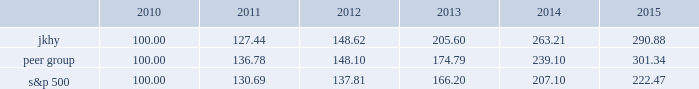18 2015 annual report performance graph the following chart presents a comparison for the five-year period ended june 30 , 2015 , of the market performance of the company 2019s common stock with the s&p 500 index and an index of peer companies selected by the company : comparison of 5 year cumulative total return among jack henry & associates , inc. , the s&p 500 index , and a peer group the following information depicts a line graph with the following values: .
This comparison assumes $ 100 was invested on june 30 , 2010 , and assumes reinvestments of dividends .
Total returns are calculated according to market capitalization of peer group members at the beginning of each period .
Peer companies selected are in the business of providing specialized computer software , hardware and related services to financial institutions and other businesses .
Companies in the peer group are aci worldwide , inc. , bottomline technology , inc. , broadridge financial solutions , cardtronics , inc. , convergys corp. , corelogic , inc. , dst systems , inc. , euronet worldwide , inc. , fair isaac corp. , fidelity national information services , inc. , fiserv , inc. , global payments , inc. , heartland payment systems , inc. , moneygram international , inc. , ss&c technologies holdings , inc. , total systems services , inc. , tyler technologies , inc. , verifone systems , inc. , and wex , inc. .
Micros systems , inc .
Was removed from the peer group as it was acquired in september 2014. .
In 2010 , what was the cumulative total return of the s&p 500? 
Computations: (130.69 - 100.00)
Answer: 30.69. 